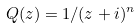<formula> <loc_0><loc_0><loc_500><loc_500>Q ( z ) = 1 / ( z + i ) ^ { n }</formula> 